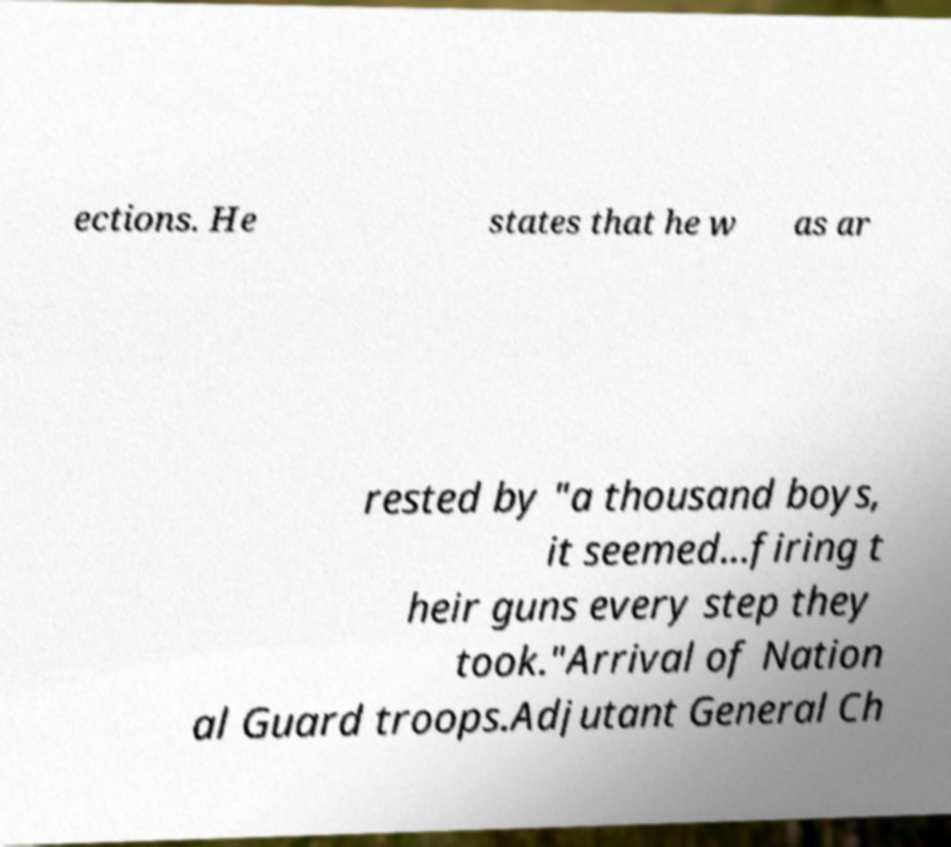I need the written content from this picture converted into text. Can you do that? ections. He states that he w as ar rested by "a thousand boys, it seemed...firing t heir guns every step they took."Arrival of Nation al Guard troops.Adjutant General Ch 